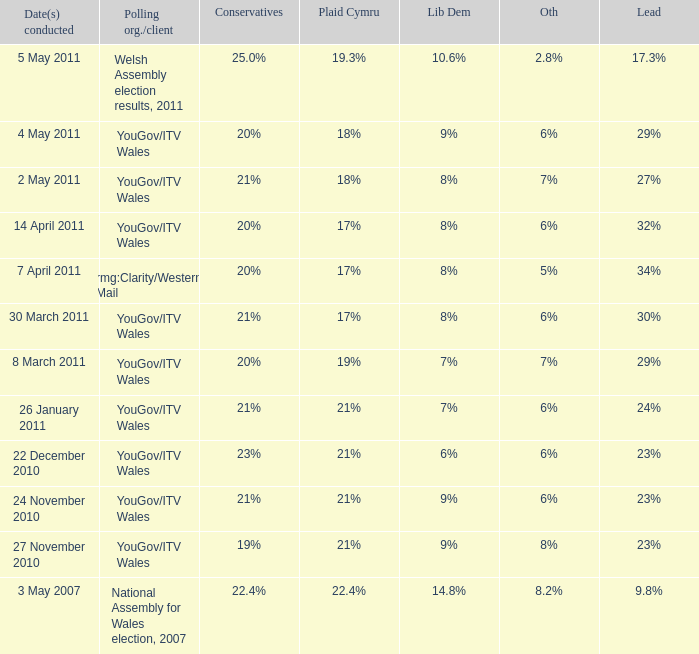Tell me the dates conducted for plaid cymru of 19% 8 March 2011. 